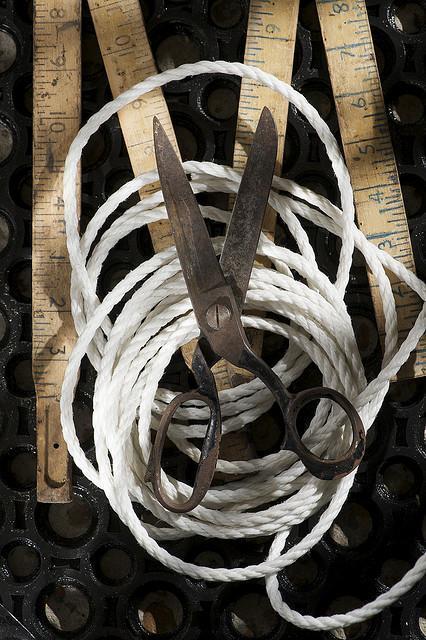How many rulers are shown?
Give a very brief answer. 4. 